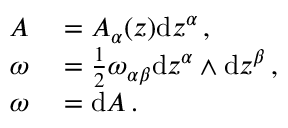<formula> <loc_0><loc_0><loc_500><loc_500>\begin{array} { r l } { A } & = A _ { \alpha } ( z ) d z ^ { \alpha } \, , } \\ { \omega } & = \frac { 1 } { 2 } \omega _ { \alpha \beta } d z ^ { \alpha } \wedge d z ^ { \beta } \, , } \\ { \omega } & = d A \, . } \end{array}</formula> 